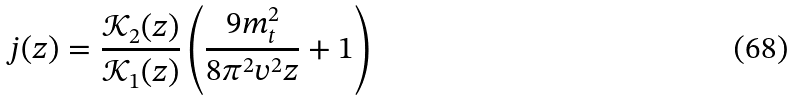Convert formula to latex. <formula><loc_0><loc_0><loc_500><loc_500>j ( z ) = \frac { \mathcal { K } _ { 2 } ( z ) } { \mathcal { K } _ { 1 } ( z ) } \left ( \frac { 9 m _ { t } ^ { 2 } } { 8 \pi ^ { 2 } v ^ { 2 } z } + 1 \right )</formula> 